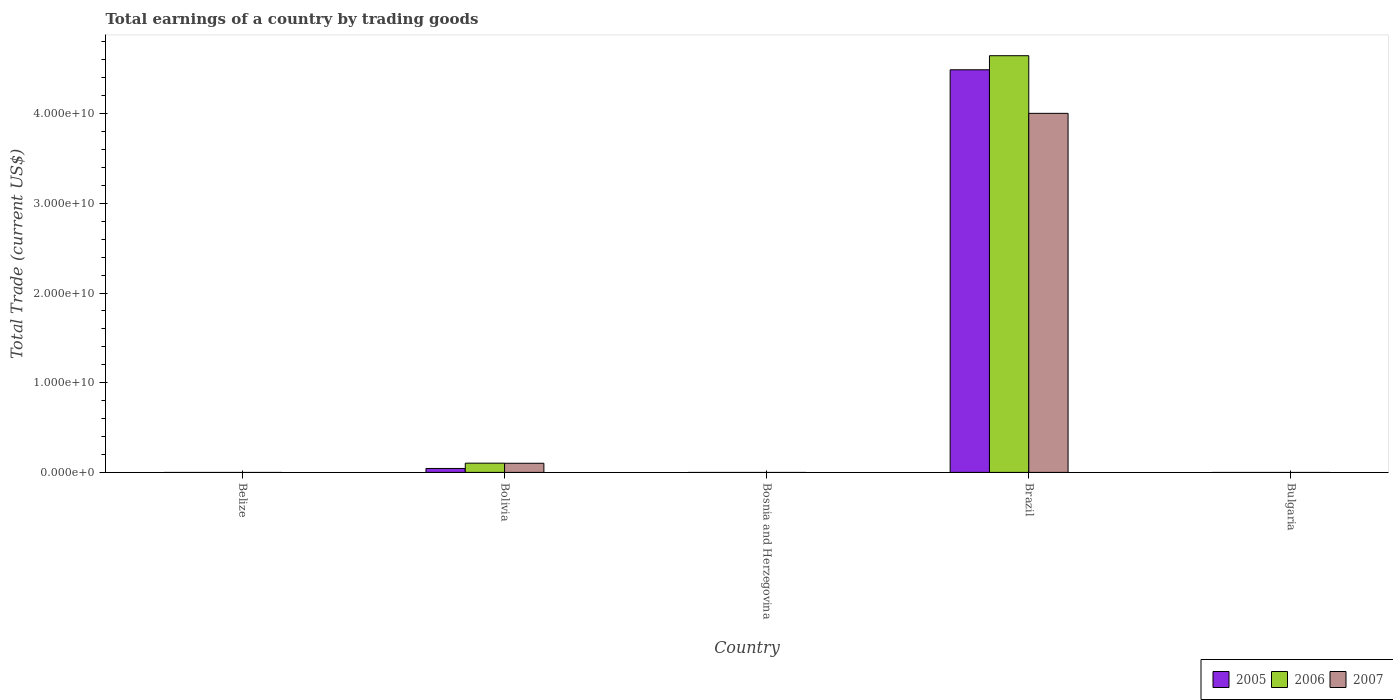How many different coloured bars are there?
Provide a short and direct response. 3. Are the number of bars per tick equal to the number of legend labels?
Provide a short and direct response. No. How many bars are there on the 1st tick from the right?
Keep it short and to the point. 0. What is the label of the 2nd group of bars from the left?
Offer a very short reply. Bolivia. In how many cases, is the number of bars for a given country not equal to the number of legend labels?
Your response must be concise. 3. Across all countries, what is the maximum total earnings in 2007?
Provide a succinct answer. 4.00e+1. Across all countries, what is the minimum total earnings in 2006?
Offer a very short reply. 0. What is the total total earnings in 2007 in the graph?
Your answer should be very brief. 4.11e+1. What is the difference between the total earnings in 2006 in Bolivia and the total earnings in 2005 in Bulgaria?
Your answer should be very brief. 1.03e+09. What is the average total earnings in 2006 per country?
Offer a very short reply. 9.50e+09. What is the difference between the total earnings of/in 2007 and total earnings of/in 2005 in Bolivia?
Your answer should be compact. 5.80e+08. In how many countries, is the total earnings in 2007 greater than 4000000000 US$?
Your answer should be very brief. 1. What is the ratio of the total earnings in 2007 in Bolivia to that in Brazil?
Your answer should be compact. 0.03. Is the total earnings in 2005 in Bolivia less than that in Brazil?
Provide a succinct answer. Yes. What is the difference between the highest and the lowest total earnings in 2007?
Ensure brevity in your answer.  4.00e+1. In how many countries, is the total earnings in 2005 greater than the average total earnings in 2005 taken over all countries?
Provide a short and direct response. 1. What is the difference between two consecutive major ticks on the Y-axis?
Make the answer very short. 1.00e+1. Are the values on the major ticks of Y-axis written in scientific E-notation?
Your response must be concise. Yes. Does the graph contain any zero values?
Offer a terse response. Yes. Does the graph contain grids?
Your answer should be compact. No. Where does the legend appear in the graph?
Your answer should be very brief. Bottom right. How many legend labels are there?
Ensure brevity in your answer.  3. What is the title of the graph?
Offer a very short reply. Total earnings of a country by trading goods. Does "1984" appear as one of the legend labels in the graph?
Give a very brief answer. No. What is the label or title of the X-axis?
Make the answer very short. Country. What is the label or title of the Y-axis?
Your answer should be compact. Total Trade (current US$). What is the Total Trade (current US$) of 2005 in Belize?
Keep it short and to the point. 0. What is the Total Trade (current US$) in 2006 in Belize?
Give a very brief answer. 0. What is the Total Trade (current US$) in 2007 in Belize?
Offer a terse response. 0. What is the Total Trade (current US$) in 2005 in Bolivia?
Provide a short and direct response. 4.40e+08. What is the Total Trade (current US$) of 2006 in Bolivia?
Your answer should be compact. 1.03e+09. What is the Total Trade (current US$) in 2007 in Bolivia?
Provide a short and direct response. 1.02e+09. What is the Total Trade (current US$) in 2005 in Bosnia and Herzegovina?
Provide a succinct answer. 0. What is the Total Trade (current US$) of 2006 in Bosnia and Herzegovina?
Ensure brevity in your answer.  0. What is the Total Trade (current US$) of 2007 in Bosnia and Herzegovina?
Your answer should be compact. 0. What is the Total Trade (current US$) of 2005 in Brazil?
Your answer should be very brief. 4.49e+1. What is the Total Trade (current US$) of 2006 in Brazil?
Your answer should be very brief. 4.65e+1. What is the Total Trade (current US$) in 2007 in Brazil?
Your answer should be compact. 4.00e+1. What is the Total Trade (current US$) of 2005 in Bulgaria?
Give a very brief answer. 0. Across all countries, what is the maximum Total Trade (current US$) in 2005?
Provide a short and direct response. 4.49e+1. Across all countries, what is the maximum Total Trade (current US$) in 2006?
Provide a succinct answer. 4.65e+1. Across all countries, what is the maximum Total Trade (current US$) in 2007?
Offer a terse response. 4.00e+1. Across all countries, what is the minimum Total Trade (current US$) of 2005?
Your response must be concise. 0. Across all countries, what is the minimum Total Trade (current US$) of 2006?
Provide a succinct answer. 0. Across all countries, what is the minimum Total Trade (current US$) in 2007?
Give a very brief answer. 0. What is the total Total Trade (current US$) of 2005 in the graph?
Your answer should be very brief. 4.53e+1. What is the total Total Trade (current US$) of 2006 in the graph?
Your answer should be very brief. 4.75e+1. What is the total Total Trade (current US$) in 2007 in the graph?
Your answer should be compact. 4.11e+1. What is the difference between the Total Trade (current US$) in 2005 in Bolivia and that in Brazil?
Keep it short and to the point. -4.44e+1. What is the difference between the Total Trade (current US$) in 2006 in Bolivia and that in Brazil?
Offer a very short reply. -4.54e+1. What is the difference between the Total Trade (current US$) of 2007 in Bolivia and that in Brazil?
Your response must be concise. -3.90e+1. What is the difference between the Total Trade (current US$) in 2005 in Bolivia and the Total Trade (current US$) in 2006 in Brazil?
Offer a very short reply. -4.60e+1. What is the difference between the Total Trade (current US$) of 2005 in Bolivia and the Total Trade (current US$) of 2007 in Brazil?
Provide a succinct answer. -3.96e+1. What is the difference between the Total Trade (current US$) in 2006 in Bolivia and the Total Trade (current US$) in 2007 in Brazil?
Provide a short and direct response. -3.90e+1. What is the average Total Trade (current US$) in 2005 per country?
Ensure brevity in your answer.  9.07e+09. What is the average Total Trade (current US$) in 2006 per country?
Ensure brevity in your answer.  9.50e+09. What is the average Total Trade (current US$) in 2007 per country?
Ensure brevity in your answer.  8.21e+09. What is the difference between the Total Trade (current US$) of 2005 and Total Trade (current US$) of 2006 in Bolivia?
Your answer should be very brief. -5.90e+08. What is the difference between the Total Trade (current US$) of 2005 and Total Trade (current US$) of 2007 in Bolivia?
Your answer should be very brief. -5.80e+08. What is the difference between the Total Trade (current US$) of 2006 and Total Trade (current US$) of 2007 in Bolivia?
Ensure brevity in your answer.  1.05e+07. What is the difference between the Total Trade (current US$) of 2005 and Total Trade (current US$) of 2006 in Brazil?
Make the answer very short. -1.57e+09. What is the difference between the Total Trade (current US$) of 2005 and Total Trade (current US$) of 2007 in Brazil?
Keep it short and to the point. 4.86e+09. What is the difference between the Total Trade (current US$) of 2006 and Total Trade (current US$) of 2007 in Brazil?
Provide a succinct answer. 6.43e+09. What is the ratio of the Total Trade (current US$) of 2005 in Bolivia to that in Brazil?
Your answer should be compact. 0.01. What is the ratio of the Total Trade (current US$) of 2006 in Bolivia to that in Brazil?
Your response must be concise. 0.02. What is the ratio of the Total Trade (current US$) in 2007 in Bolivia to that in Brazil?
Make the answer very short. 0.03. What is the difference between the highest and the lowest Total Trade (current US$) in 2005?
Give a very brief answer. 4.49e+1. What is the difference between the highest and the lowest Total Trade (current US$) of 2006?
Your response must be concise. 4.65e+1. What is the difference between the highest and the lowest Total Trade (current US$) in 2007?
Make the answer very short. 4.00e+1. 